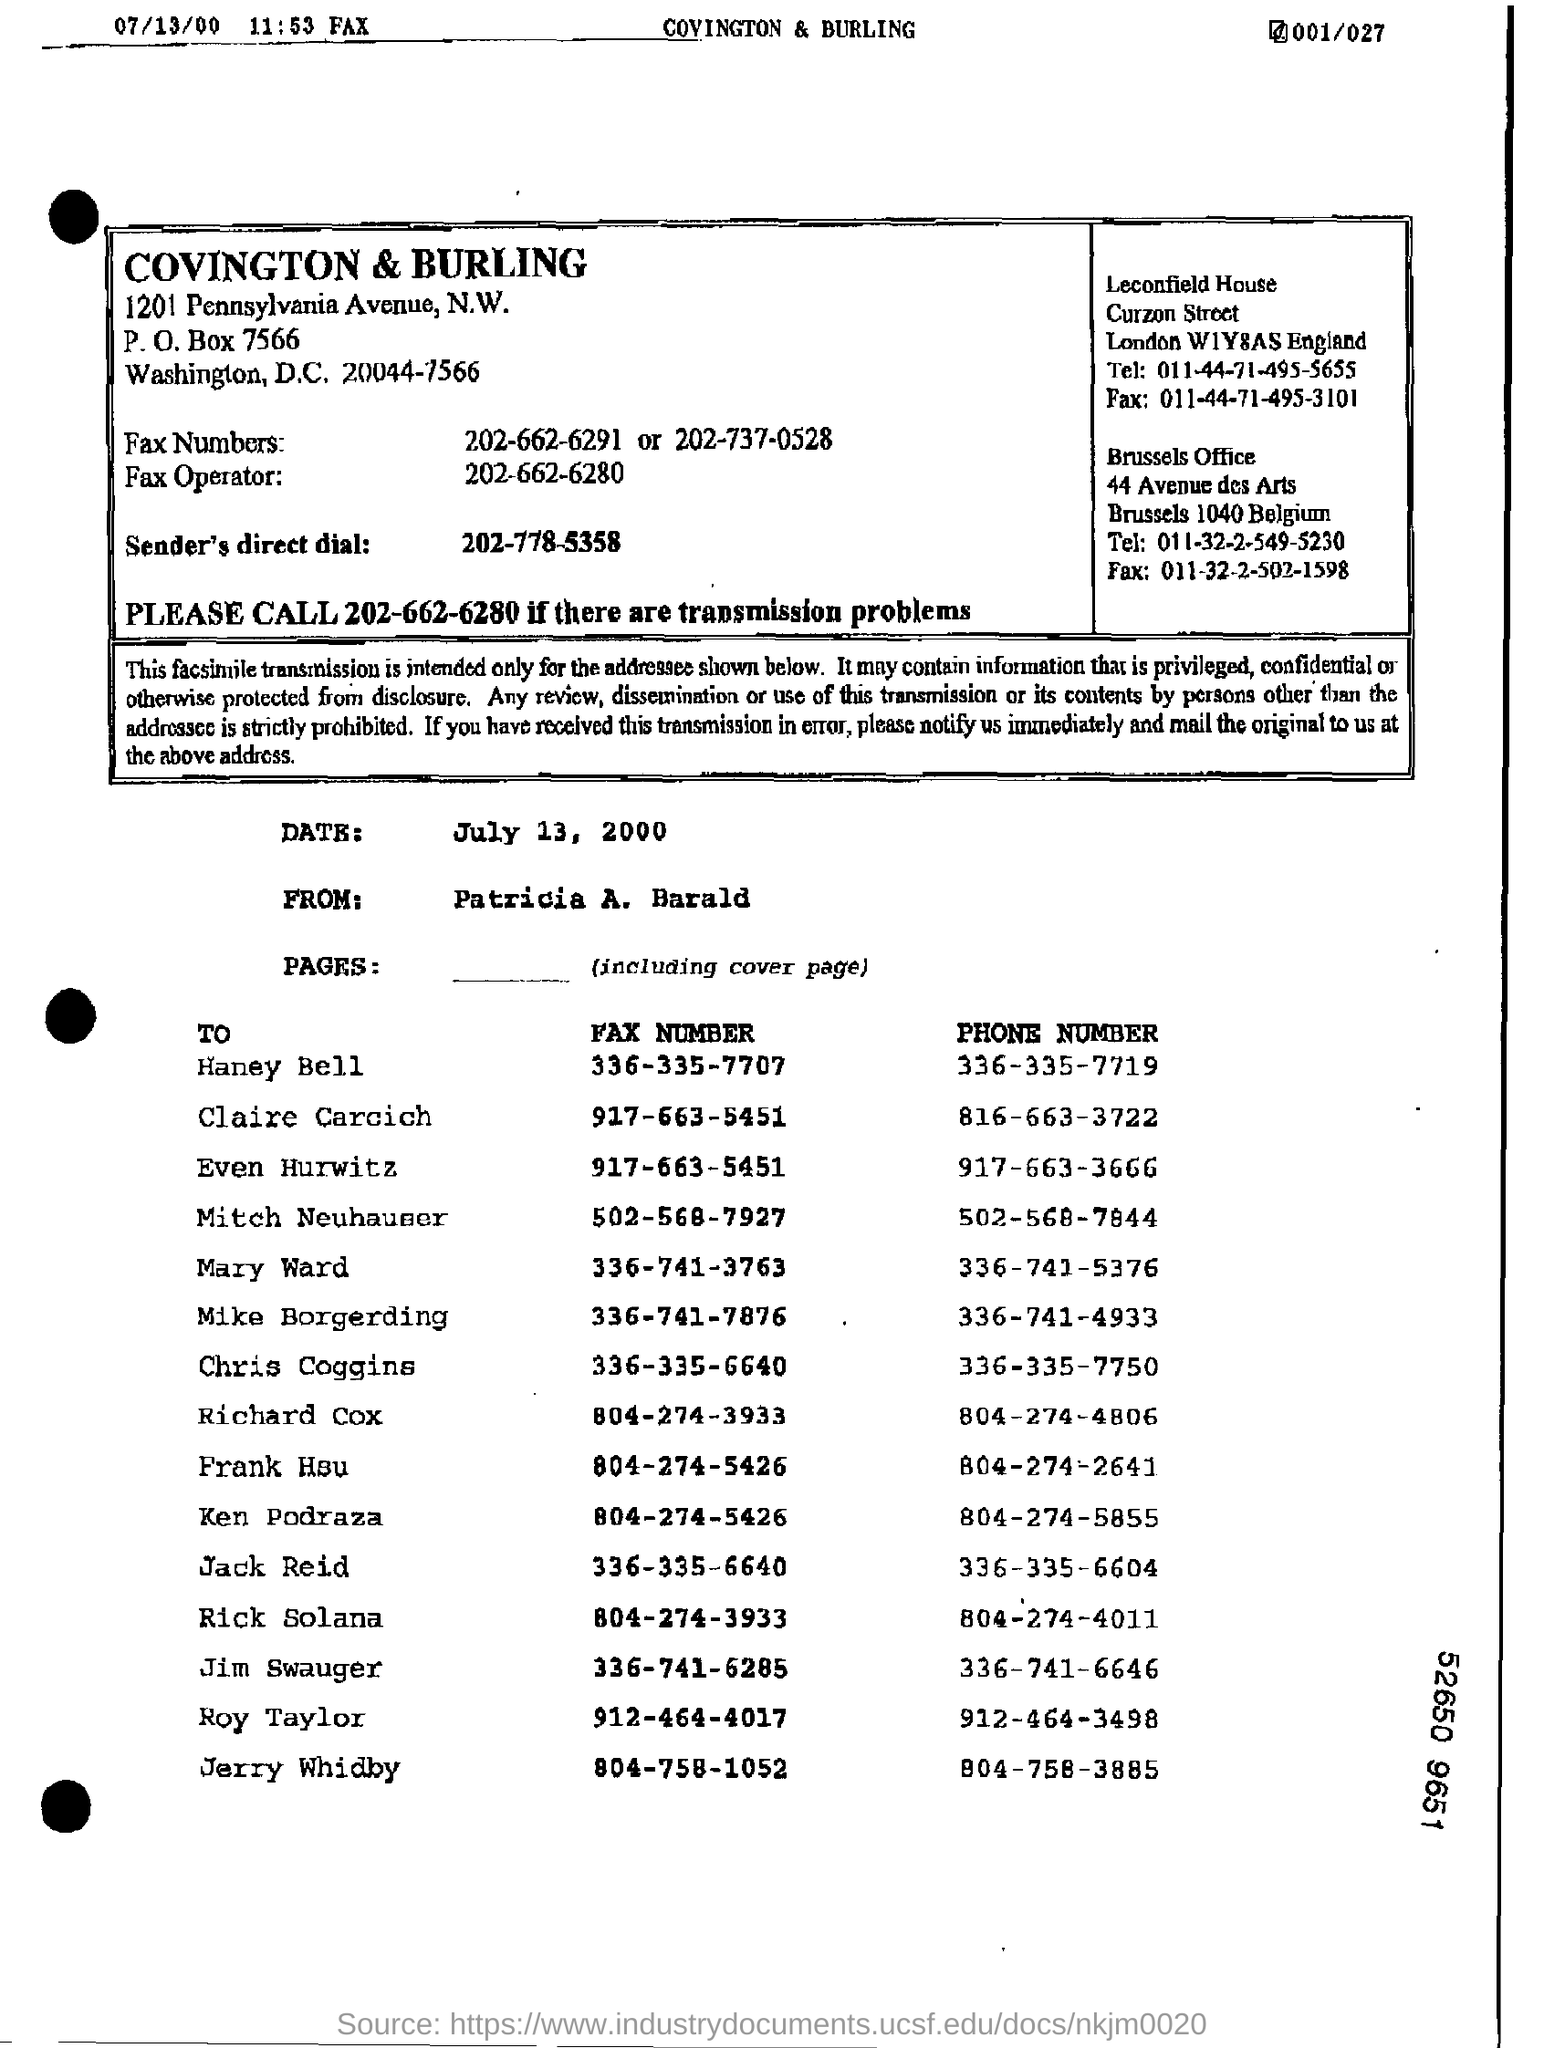Draw attention to some important aspects in this diagram. The heading in the box is 'COVINGTON & BURLING..'. The person whose fax number is 336-335-7707 is Haney Bell. The date mentioned below the box is July 13, 2000. The last phone number on the list is Jerry Whidby's. 